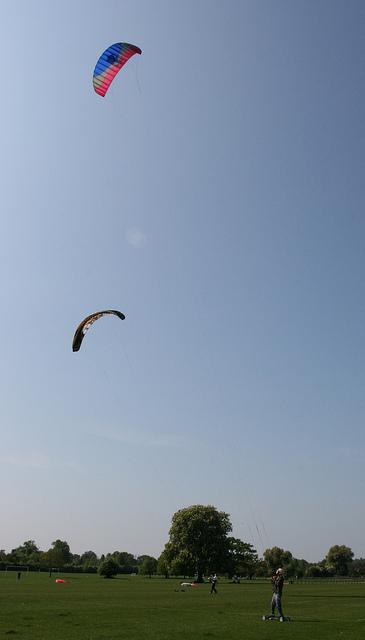Is there a storm coming?
Keep it brief. No. What is the location of the kites being flown?
Quick response, please. Sky. How many kites are pictured?
Concise answer only. 2. Where is this scene?
Short answer required. Park. Is the weather sunny?
Answer briefly. Yes. Where are the people flying kites?
Be succinct. Park. Are these kites used for a sport?
Write a very short answer. Yes. What game is being played on the ground?
Quick response, please. Frisbee. Is this a sunny day?
Quick response, please. Yes. How many kites are in the air?
Be succinct. 2. 